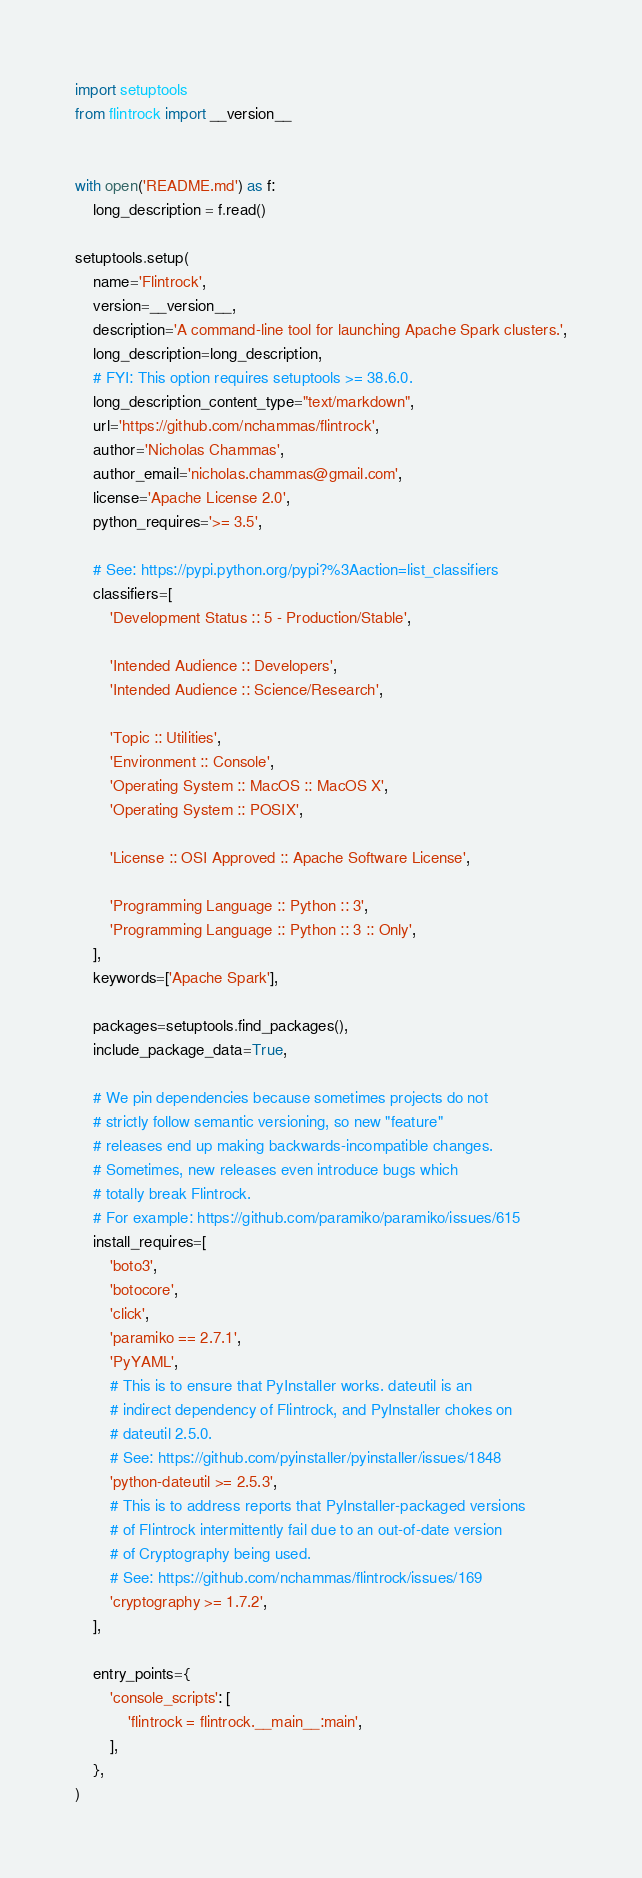<code> <loc_0><loc_0><loc_500><loc_500><_Python_>import setuptools
from flintrock import __version__


with open('README.md') as f:
    long_description = f.read()

setuptools.setup(
    name='Flintrock',
    version=__version__,
    description='A command-line tool for launching Apache Spark clusters.',
    long_description=long_description,
    # FYI: This option requires setuptools >= 38.6.0.
    long_description_content_type="text/markdown",
    url='https://github.com/nchammas/flintrock',
    author='Nicholas Chammas',
    author_email='nicholas.chammas@gmail.com',
    license='Apache License 2.0',
    python_requires='>= 3.5',

    # See: https://pypi.python.org/pypi?%3Aaction=list_classifiers
    classifiers=[
        'Development Status :: 5 - Production/Stable',

        'Intended Audience :: Developers',
        'Intended Audience :: Science/Research',

        'Topic :: Utilities',
        'Environment :: Console',
        'Operating System :: MacOS :: MacOS X',
        'Operating System :: POSIX',

        'License :: OSI Approved :: Apache Software License',

        'Programming Language :: Python :: 3',
        'Programming Language :: Python :: 3 :: Only',
    ],
    keywords=['Apache Spark'],

    packages=setuptools.find_packages(),
    include_package_data=True,

    # We pin dependencies because sometimes projects do not
    # strictly follow semantic versioning, so new "feature"
    # releases end up making backwards-incompatible changes.
    # Sometimes, new releases even introduce bugs which
    # totally break Flintrock.
    # For example: https://github.com/paramiko/paramiko/issues/615
    install_requires=[
        'boto3',
        'botocore',
        'click',
        'paramiko == 2.7.1',
        'PyYAML',
        # This is to ensure that PyInstaller works. dateutil is an
        # indirect dependency of Flintrock, and PyInstaller chokes on
        # dateutil 2.5.0.
        # See: https://github.com/pyinstaller/pyinstaller/issues/1848
        'python-dateutil >= 2.5.3',
        # This is to address reports that PyInstaller-packaged versions
        # of Flintrock intermittently fail due to an out-of-date version
        # of Cryptography being used.
        # See: https://github.com/nchammas/flintrock/issues/169
        'cryptography >= 1.7.2',
    ],

    entry_points={
        'console_scripts': [
            'flintrock = flintrock.__main__:main',
        ],
    },
)
</code> 